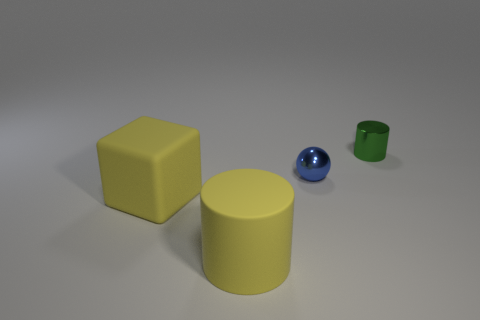Add 2 tiny blue metal balls. How many objects exist? 6 Subtract all blocks. How many objects are left? 3 Subtract all brown matte things. Subtract all big matte things. How many objects are left? 2 Add 1 yellow matte cylinders. How many yellow matte cylinders are left? 2 Add 2 green objects. How many green objects exist? 3 Subtract 1 yellow cylinders. How many objects are left? 3 